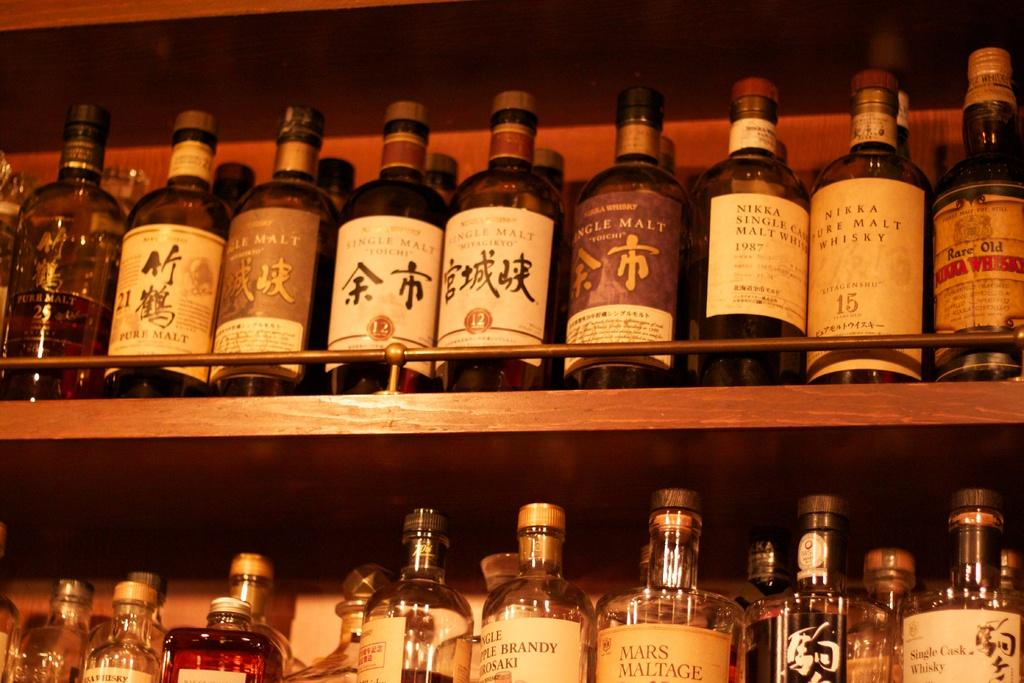<image>
Write a terse but informative summary of the picture. Different bottles of a malt drink are lined up in shelves. 